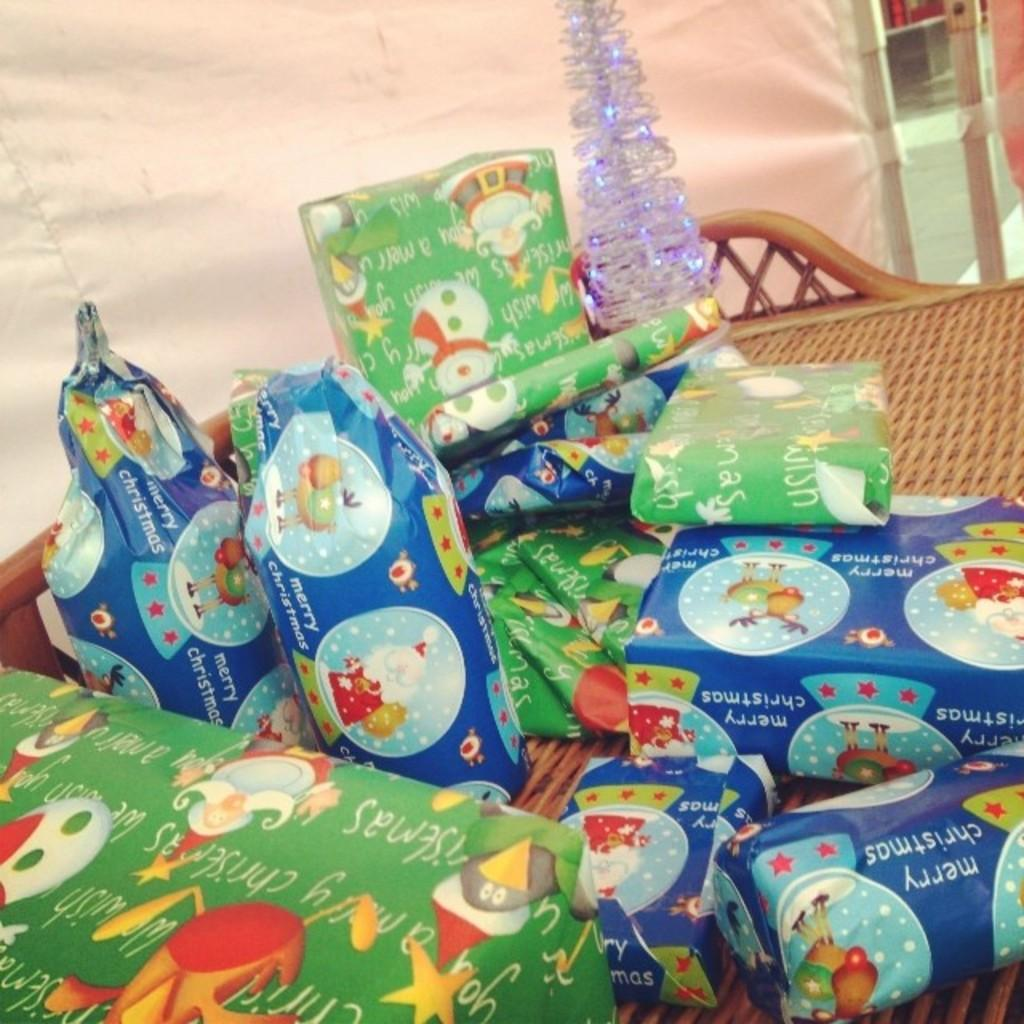What is the main object in the image? There is an object in the image, but its specific nature is not mentioned in the facts. What else can be seen in the image besides the main object? Gift packets and a basket are visible in the image. What type of material is present in the image? Cloth is present in the image. What else can be observed in the background of the image? There are unspecified objects in the background of the image. How many carriages are visible in the image? There is no carriage present in the image. What type of net is used to cover the gift packets in the image? There is no net mentioned or visible in the image; the gift packets are not covered. 